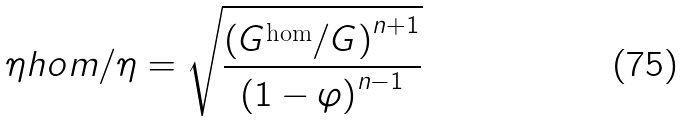Convert formula to latex. <formula><loc_0><loc_0><loc_500><loc_500>\eta h o m / \eta = \sqrt { \frac { \left ( G ^ { \text {hom} } / G \right ) ^ { n + 1 } } { \left ( 1 - \varphi \right ) ^ { n - 1 } } }</formula> 